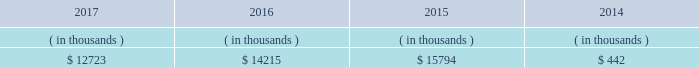The city council 2019s advisors and entergy new orleans .
In february 2018 the city council approved the settlement , which deferred cost recovery to the 2018 entergy new orleans rate case , but also stated that an adjustment for 2018-2019 ami costs can be filed in the rate case and that , for all subsequent ami costs , the mechanism to be approved in the 2018 rate case will allow for the timely recovery of such costs .
Sources of capital entergy new orleans 2019s sources to meet its capital requirements include : 2022 internally generated funds ; 2022 cash on hand ; 2022 debt and preferred membership interest issuances ; and 2022 bank financing under new or existing facilities .
Entergy new orleans may refinance , redeem , or otherwise retire debt prior to maturity , to the extent market conditions and interest rates are favorable .
Entergy new orleans 2019s receivables from the money pool were as follows as of december 31 for each of the following years. .
See note 4 to the financial statements for a description of the money pool .
Entergy new orleans has a credit facility in the amount of $ 25 million scheduled to expire in november 2018 .
The credit facility allows entergy new orleans to issue letters of credit against $ 10 million of the borrowing capacity of the facility .
As of december 31 , 2017 , there were no cash borrowings and a $ 0.8 million letter of credit was outstanding under the facility .
In addition , entergy new orleans is a party to an uncommitted letter of credit facility as a means to post collateral to support its obligations to miso . a0 as of december 31 , 2017 , a $ 1.4 million letter of credit was outstanding under entergy new orleans 2019s letter of credit a0facility .
See note 4 to the financial statements for additional discussion of the credit facilities .
Entergy new orleans obtained authorization from the ferc through october 2019 for short-term borrowings not to exceed an aggregate amount of $ 150 million at any time outstanding and long-term borrowings and securities issuances .
See note 4 to the financial statements for further discussion of entergy new orleans 2019s short-term borrowing limits .
The long-term securities issuances of entergy new orleans are limited to amounts authorized not only by the ferc , but also by the city council , and the current city council authorization extends through june 2018 .
Entergy new orleans , llc and subsidiaries management 2019s financial discussion and analysis state and local rate regulation the rates that entergy new orleans charges for electricity and natural gas significantly influence its financial position , results of operations , and liquidity .
Entergy new orleans is regulated and the rates charged to its customers are determined in regulatory proceedings .
A governmental agency , the city council , is primarily responsible for approval of the rates charged to customers .
Retail rates see 201calgiers asset transfer 201d below for discussion of the algiers asset transfer .
As a provision of the settlement agreement approved by the city council in may 2015 providing for the algiers asset transfer , it was agreed that , with limited exceptions , no action may be taken with respect to entergy new orleans 2019s base rates until rates are implemented .
How much less than 2016 did entergy receive from the money pool in 2017 ? ( in thousand $ )? 
Computations: (14215 - 12723)
Answer: 1492.0. 